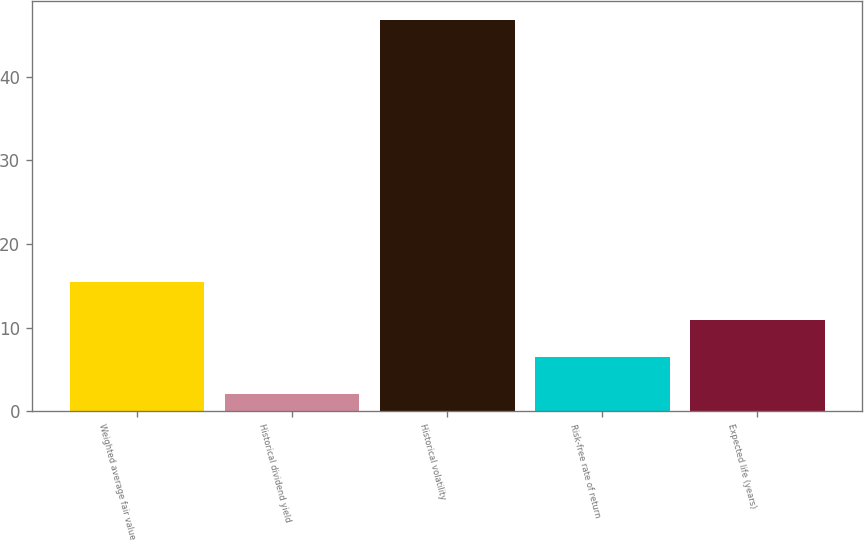Convert chart to OTSL. <chart><loc_0><loc_0><loc_500><loc_500><bar_chart><fcel>Weighted average fair value<fcel>Historical dividend yield<fcel>Historical volatility<fcel>Risk-free rate of return<fcel>Expected life (years)<nl><fcel>15.41<fcel>2<fcel>46.7<fcel>6.47<fcel>10.94<nl></chart> 